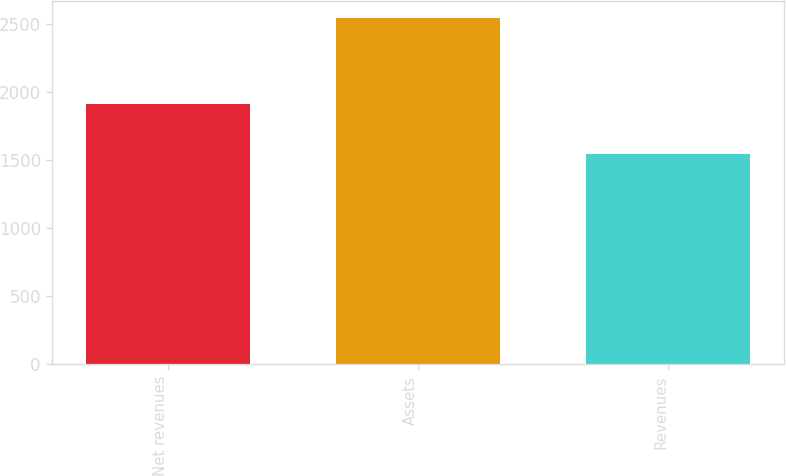Convert chart to OTSL. <chart><loc_0><loc_0><loc_500><loc_500><bar_chart><fcel>Net revenues<fcel>Assets<fcel>Revenues<nl><fcel>1911.5<fcel>2543<fcel>1545.7<nl></chart> 